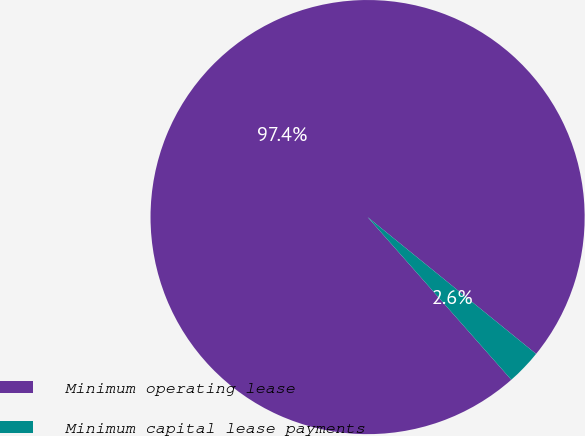<chart> <loc_0><loc_0><loc_500><loc_500><pie_chart><fcel>Minimum operating lease<fcel>Minimum capital lease payments<nl><fcel>97.37%<fcel>2.63%<nl></chart> 